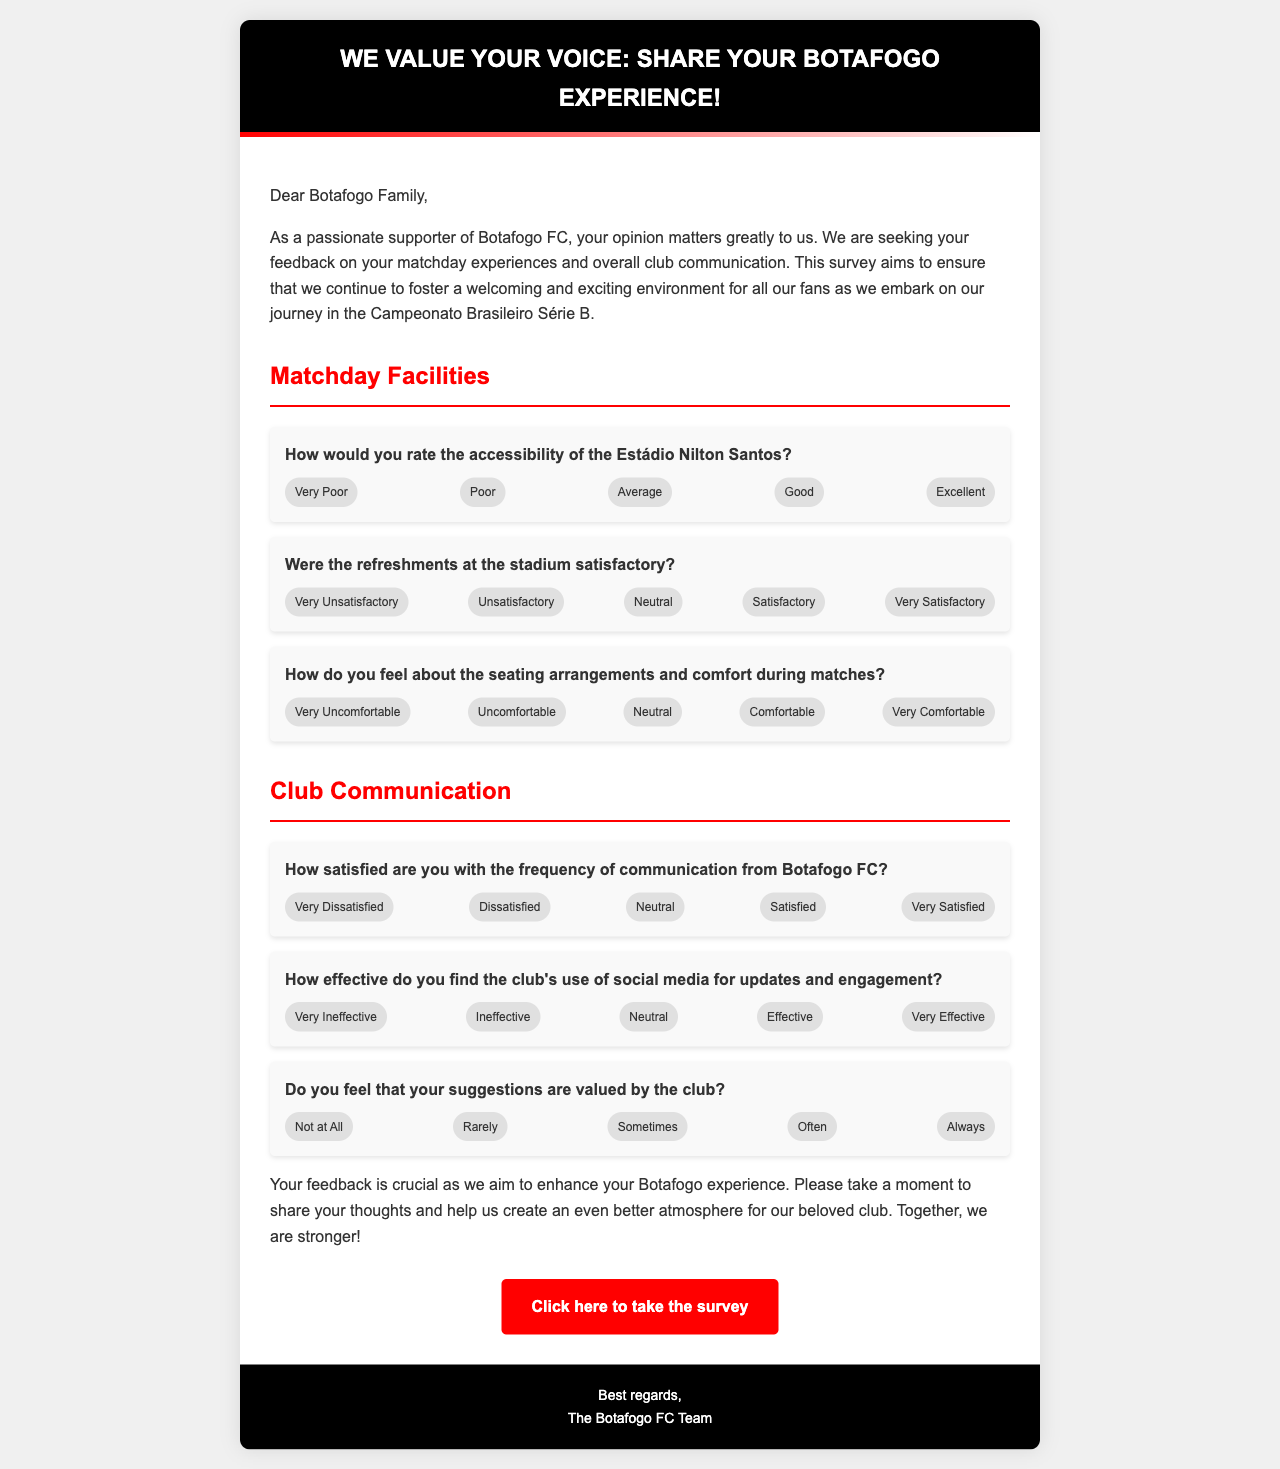What is the title of the survey email? The title of the survey email is presented prominently at the top of the document.
Answer: We Value Your Voice: Share Your Botafogo Experience! What is the primary purpose of the survey? The primary purpose of the survey is explicitly stated in the introductory paragraph.
Answer: To gather feedback on matchday experiences and overall club communication What are the five options for rating the accessibility of the Estádio Nilton Santos? The available options are listed under the question regarding accessibility.
Answer: Very Poor, Poor, Average, Good, Excellent How many questions are related to matchday facilities? The number of questions is determined by counting the items under the Matchday Facilities section.
Answer: Three What does the club want to understand through the communication feedback? The intent is summarized in the section on Club Communication regarding how often they communicate.
Answer: Frequency of communication Which color is used for the header background? The document specifies the color used for the header in the style section.
Answer: Black How is the club's communication effectiveness rated in the survey? The effectiveness rating is provided in the context of a specific question regarding social media updates.
Answer: Very Ineffective, Ineffective, Neutral, Effective, Very Effective What button is provided to access the survey? The document includes a call to action, which specifies the content of the button.
Answer: Click here to take the survey What is indicated by the gradient line at the bottom of the header? The design features a visual element that enhances the aesthetic of the header.
Answer: A gradient effect from red to white How does the survey address fans’ perceptions of their suggestions? The document includes a specific question to gauge how valued fans feel about their suggestions.
Answer: Do you feel that your suggestions are valued by the club? 